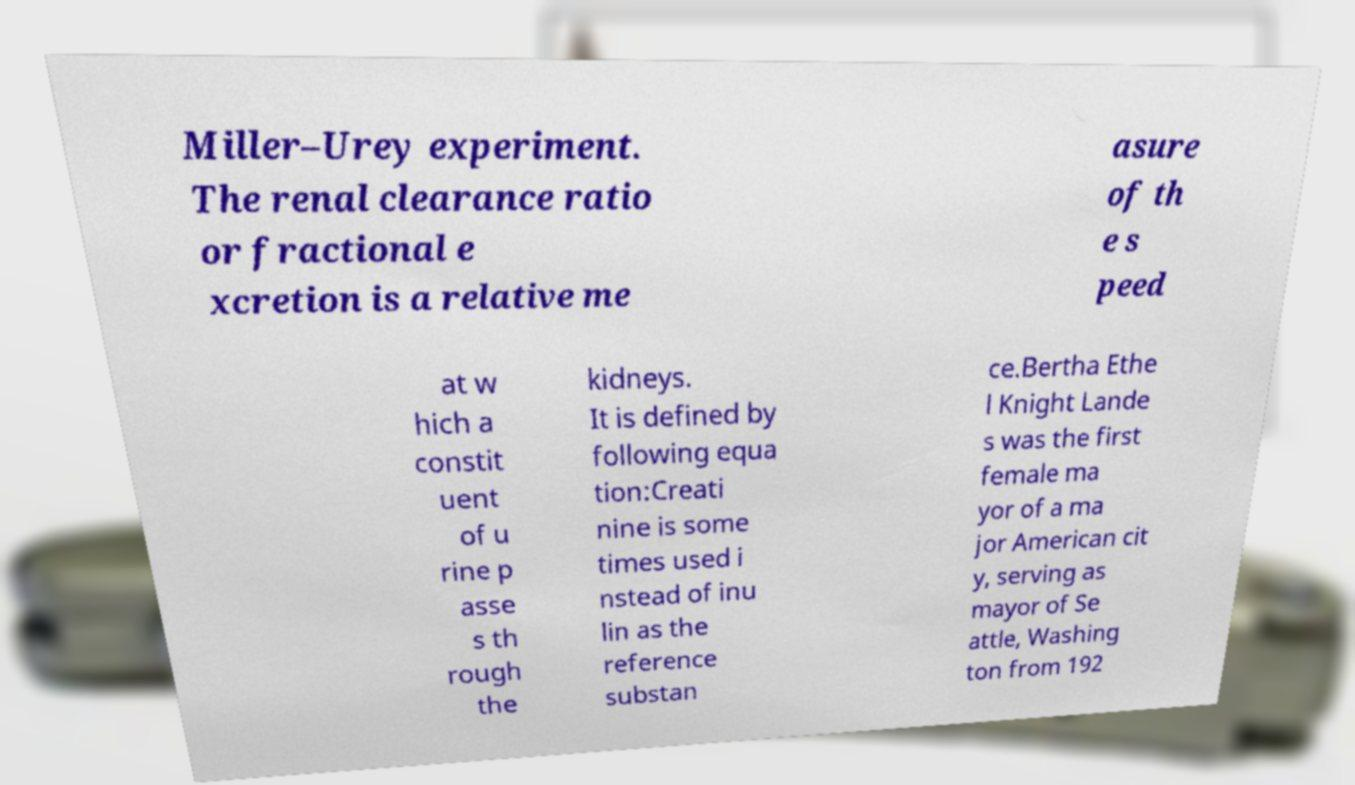Could you extract and type out the text from this image? Miller–Urey experiment. The renal clearance ratio or fractional e xcretion is a relative me asure of th e s peed at w hich a constit uent of u rine p asse s th rough the kidneys. It is defined by following equa tion:Creati nine is some times used i nstead of inu lin as the reference substan ce.Bertha Ethe l Knight Lande s was the first female ma yor of a ma jor American cit y, serving as mayor of Se attle, Washing ton from 192 